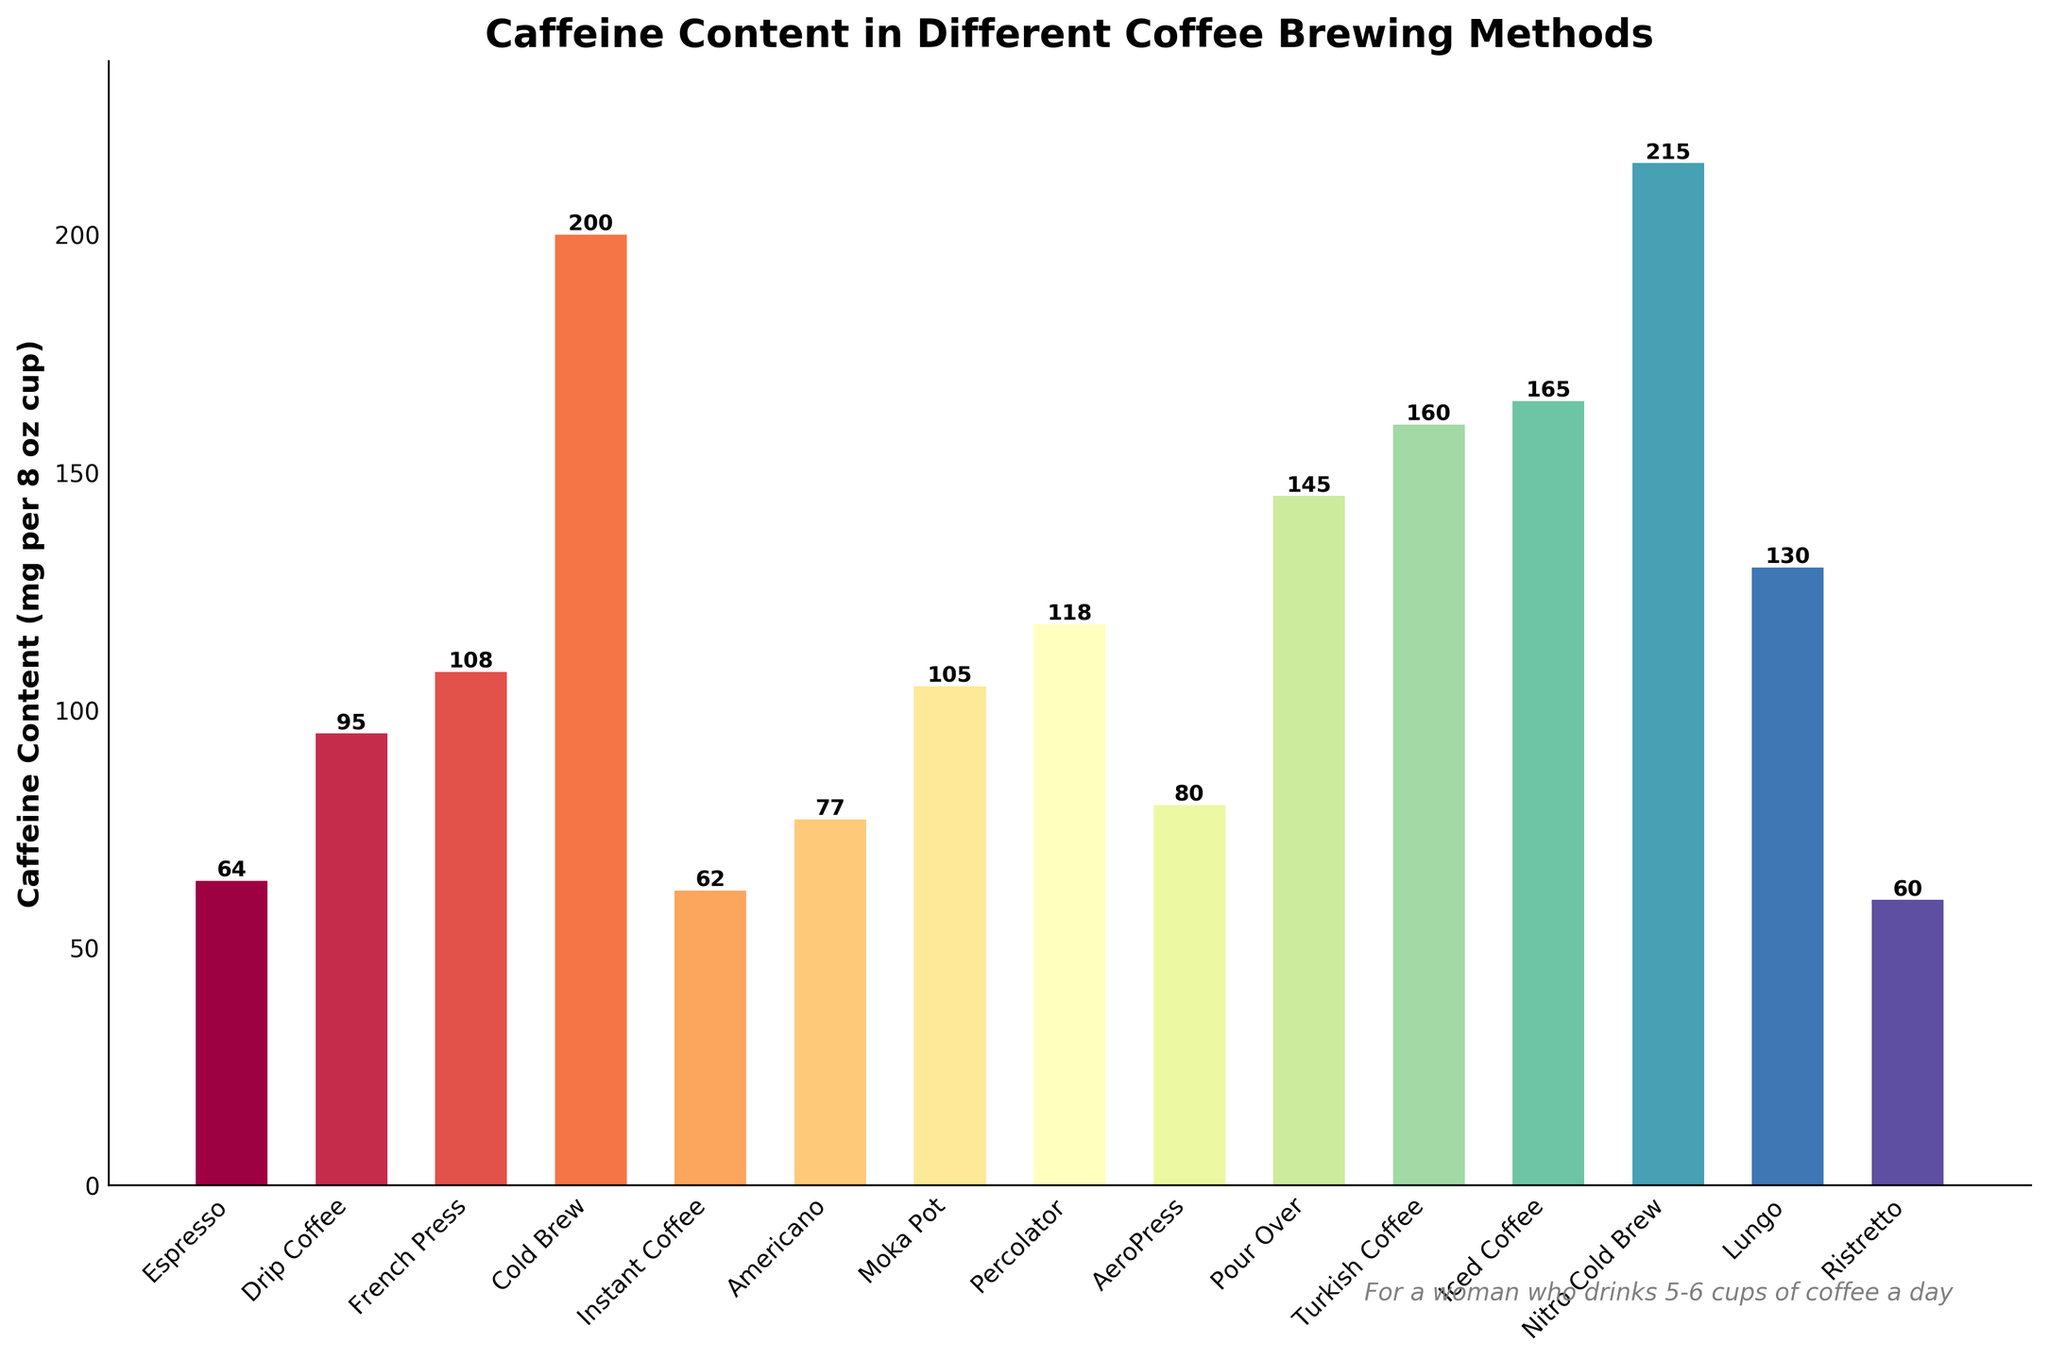Which brewing method has the highest caffeine content? By observing the height of the bars, Nitro Cold Brew has the tallest bar, indicating it has the highest caffeine content.
Answer: Nitro Cold Brew What's the difference in caffeine content between Espresso and Nitro Cold Brew? The height of the Nitro Cold Brew bar is 215 mg, and the height of the Espresso bar is 64 mg. Subtracting 64 from 215 gives the difference in caffeine content.
Answer: 151 mg What is the combined caffeine content of French Press, Moka Pot, and Percolator? French Press has 108 mg, Moka Pot has 105 mg, and Percolator has 118 mg. Adding these gives 108 + 105 + 118.
Answer: 331 mg Which brewing method has less caffeine content: Espresso or Instant Coffee? Comparing the heights of the bars, Espresso has 64 mg and Instant Coffee has 62 mg, so Instant Coffee has less caffeine.
Answer: Instant Coffee How many brewing methods have caffeine content greater than 100 mg per cup? Bars for French Press, Cold Brew, Moka Pot, Percolator, Pour Over, Turkish Coffee, Iced Coffee, Nitro Cold Brew, and Lungo exceed 100 mg. Counting these methods gives us 9.
Answer: 9 methods Is the caffeine content of Iced Coffee more or less than that of Turkish Coffee? Comparing the heights, Iced Coffee has 165 mg and Turkish Coffee has 160 mg. Iced Coffee has more caffeine content.
Answer: Iced Coffee What is the average caffeine content of methods with less than 100 mg of caffeine per cup? The methods under 100 mg are Espresso (64 mg), Instant Coffee (62 mg), Americano (77 mg), AeroPress (80 mg), and Ristretto (60 mg). Their average is calculated as (64 + 62 + 77 + 80 + 60)/5.
Answer: 68.6 mg Which brewing method has the closest caffeine content to 130 mg? Lungo has 130 mg, which matches precisely with the given value.
Answer: Lungo What is the caffeine content difference between the brewing method with the second highest and the method with the second lowest caffeine content? The second highest is Iced Coffee with 165 mg and the second lowest is Ristretto with 60 mg. Subtracting 60 from 165 gives the difference.
Answer: 105 mg If you drink 2 cups of Lungo and 1 cup of Nitro Cold Brew, how much total caffeine would you consume? Lungo has 130 mg per cup and Nitro Cold Brew has 215 mg per cup. Consuming 2 cups of Lungo and 1 cup of Nitro Cold Brew gives (2*130) + 215.
Answer: 475 mg 